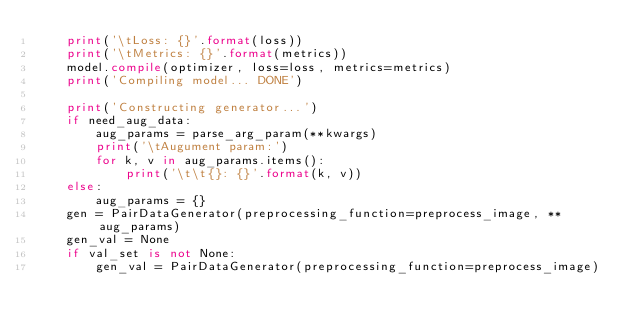<code> <loc_0><loc_0><loc_500><loc_500><_Python_>    print('\tLoss: {}'.format(loss))
    print('\tMetrics: {}'.format(metrics))
    model.compile(optimizer, loss=loss, metrics=metrics)
    print('Compiling model... DONE')

    print('Constructing generator...')
    if need_aug_data:
        aug_params = parse_arg_param(**kwargs)
        print('\tAugument param:')
        for k, v in aug_params.items():
            print('\t\t{}: {}'.format(k, v))
    else:
        aug_params = {}
    gen = PairDataGenerator(preprocessing_function=preprocess_image, **aug_params)
    gen_val = None
    if val_set is not None:
        gen_val = PairDataGenerator(preprocessing_function=preprocess_image)
</code> 